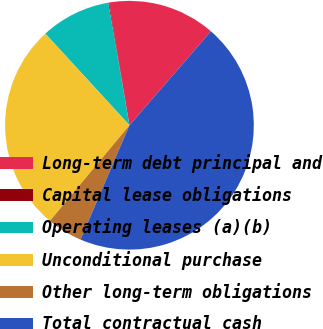Convert chart. <chart><loc_0><loc_0><loc_500><loc_500><pie_chart><fcel>Long-term debt principal and<fcel>Capital lease obligations<fcel>Operating leases (a)(b)<fcel>Unconditional purchase<fcel>Other long-term obligations<fcel>Total contractual cash<nl><fcel>13.99%<fcel>0.1%<fcel>9.1%<fcel>27.14%<fcel>4.6%<fcel>45.06%<nl></chart> 